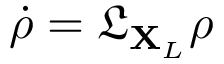Convert formula to latex. <formula><loc_0><loc_0><loc_500><loc_500>\dot { \rho } = \mathfrak { L } _ { X _ { L } } \rho</formula> 